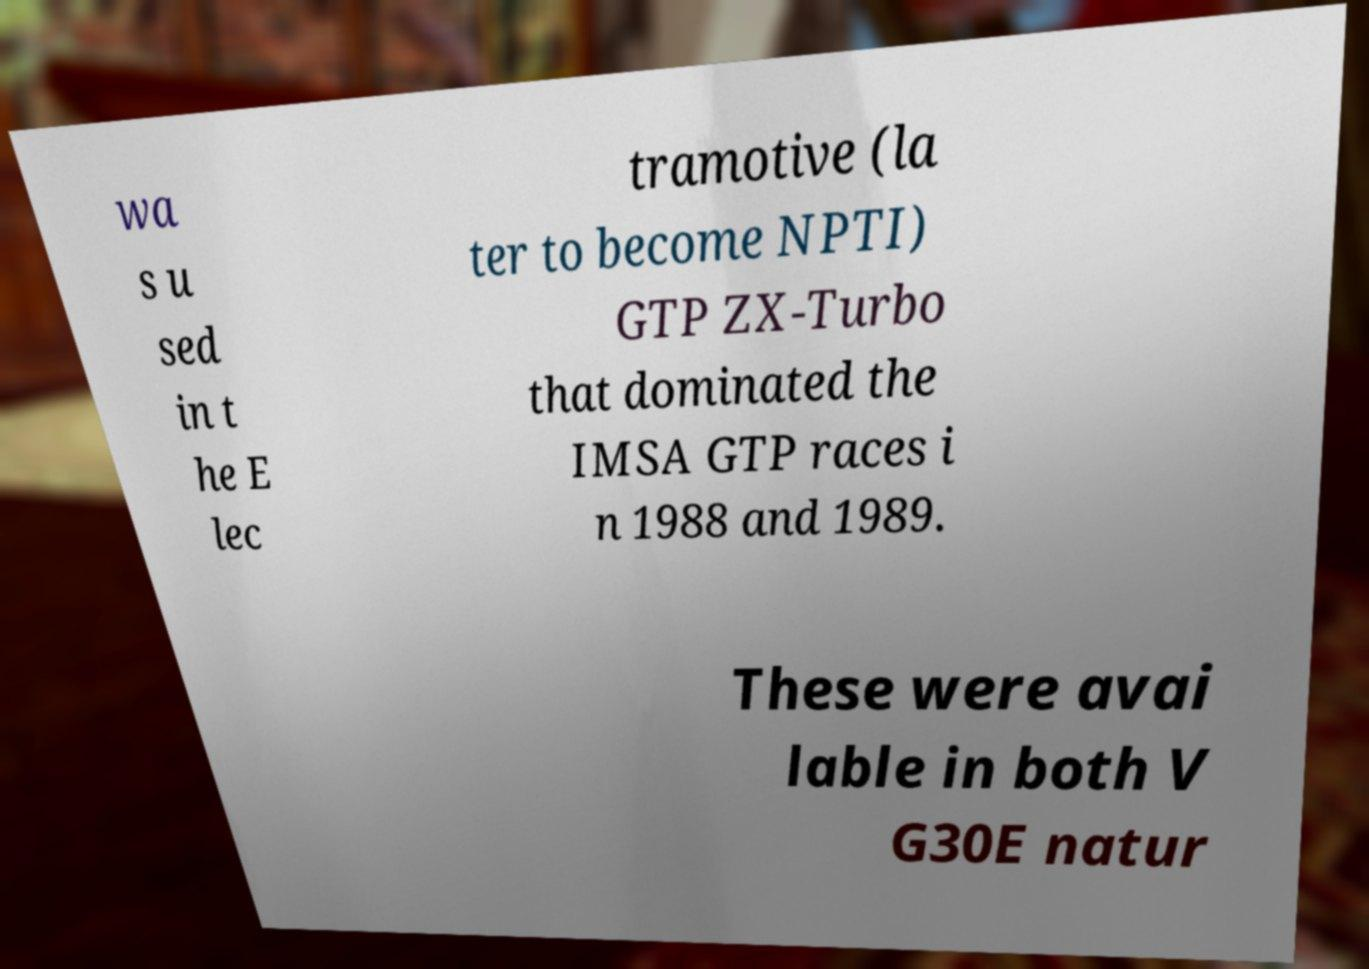Can you accurately transcribe the text from the provided image for me? wa s u sed in t he E lec tramotive (la ter to become NPTI) GTP ZX-Turbo that dominated the IMSA GTP races i n 1988 and 1989. These were avai lable in both V G30E natur 